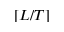<formula> <loc_0><loc_0><loc_500><loc_500>[ L / T ]</formula> 